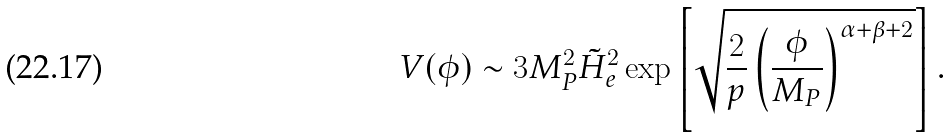<formula> <loc_0><loc_0><loc_500><loc_500>V ( \phi ) \sim 3 M _ { P } ^ { 2 } { \tilde { H } } _ { e } ^ { 2 } \exp \left [ \sqrt { \frac { 2 } { p } \left ( \frac { \phi } { M _ { P } } \right ) ^ { \alpha + \beta + 2 } } \right ] .</formula> 